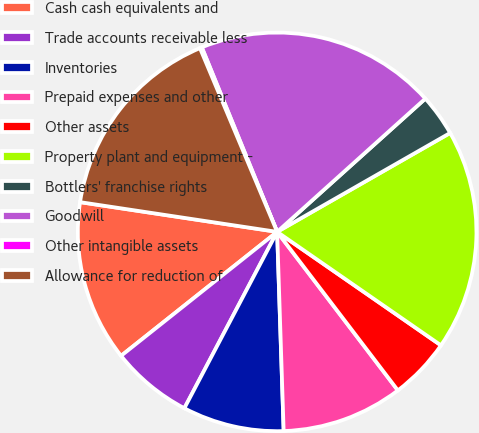Convert chart to OTSL. <chart><loc_0><loc_0><loc_500><loc_500><pie_chart><fcel>Cash cash equivalents and<fcel>Trade accounts receivable less<fcel>Inventories<fcel>Prepaid expenses and other<fcel>Other assets<fcel>Property plant and equipment -<fcel>Bottlers' franchise rights<fcel>Goodwill<fcel>Other intangible assets<fcel>Allowance for reduction of<nl><fcel>13.07%<fcel>6.61%<fcel>8.23%<fcel>9.84%<fcel>5.0%<fcel>17.91%<fcel>3.39%<fcel>19.52%<fcel>0.16%<fcel>16.29%<nl></chart> 